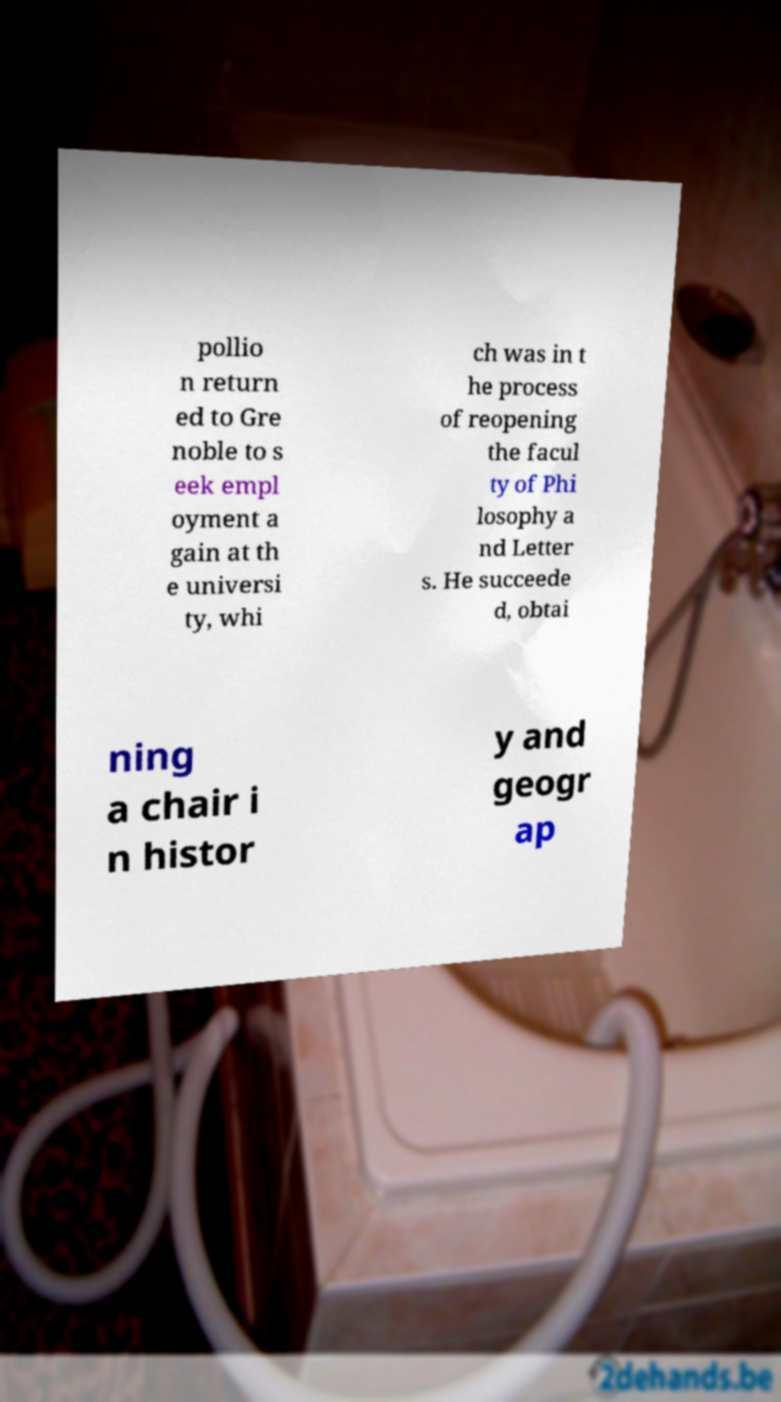Could you extract and type out the text from this image? pollio n return ed to Gre noble to s eek empl oyment a gain at th e universi ty, whi ch was in t he process of reopening the facul ty of Phi losophy a nd Letter s. He succeede d, obtai ning a chair i n histor y and geogr ap 